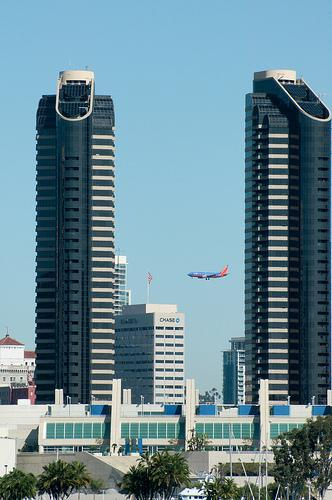Question: how many planes are there?
Choices:
A. 2.
B. 4.
C. 3.
D. 1.
Answer with the letter. Answer: D Question: where is the flag?
Choices:
A. On the pole.
B. On the house.
C. On the building.
D. On the wall.
Answer with the letter. Answer: C Question: what color are the light poles?
Choices:
A. Black.
B. Gray.
C. White.
D. Blue.
Answer with the letter. Answer: B 